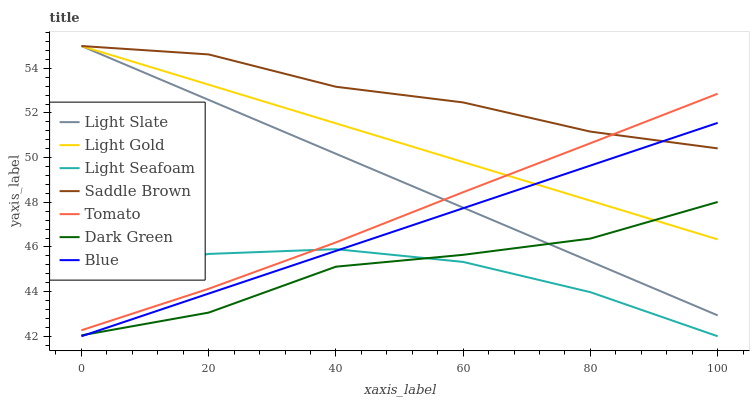Does Light Seafoam have the minimum area under the curve?
Answer yes or no. Yes. Does Saddle Brown have the maximum area under the curve?
Answer yes or no. Yes. Does Blue have the minimum area under the curve?
Answer yes or no. No. Does Blue have the maximum area under the curve?
Answer yes or no. No. Is Light Gold the smoothest?
Answer yes or no. Yes. Is Dark Green the roughest?
Answer yes or no. Yes. Is Blue the smoothest?
Answer yes or no. No. Is Blue the roughest?
Answer yes or no. No. Does Blue have the lowest value?
Answer yes or no. Yes. Does Light Slate have the lowest value?
Answer yes or no. No. Does Saddle Brown have the highest value?
Answer yes or no. Yes. Does Blue have the highest value?
Answer yes or no. No. Is Dark Green less than Tomato?
Answer yes or no. Yes. Is Tomato greater than Blue?
Answer yes or no. Yes. Does Light Slate intersect Dark Green?
Answer yes or no. Yes. Is Light Slate less than Dark Green?
Answer yes or no. No. Is Light Slate greater than Dark Green?
Answer yes or no. No. Does Dark Green intersect Tomato?
Answer yes or no. No. 